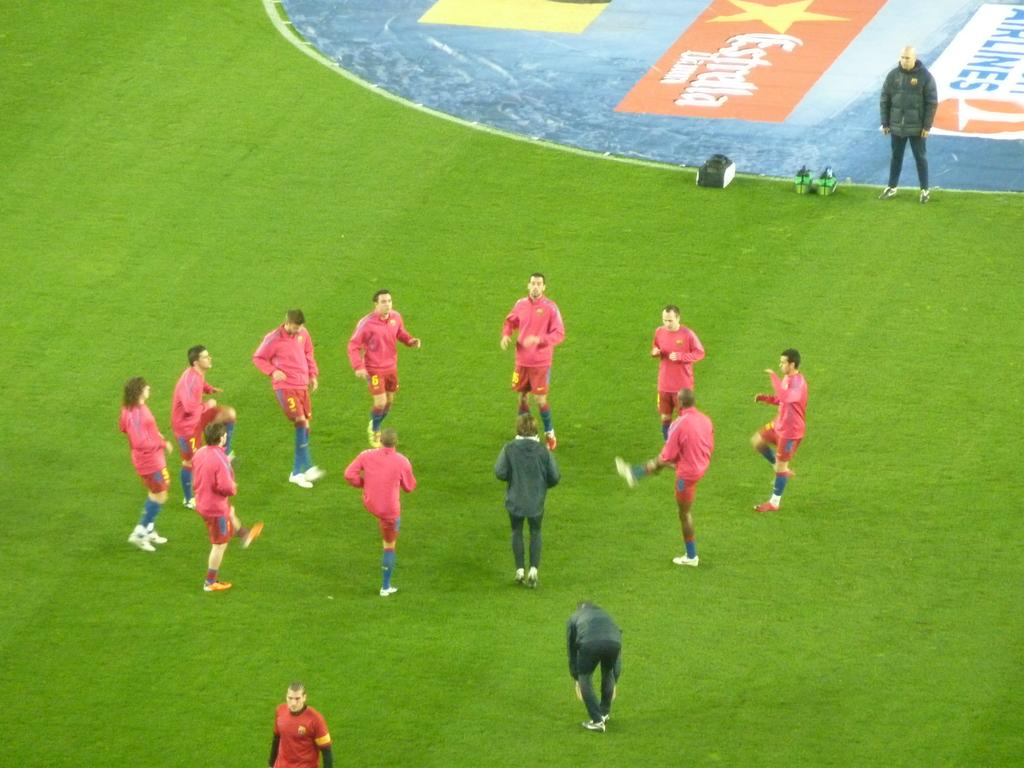<image>
Give a short and clear explanation of the subsequent image. A number of soccer players are in a circle near an ad for something Airlines that is painted into the field. 